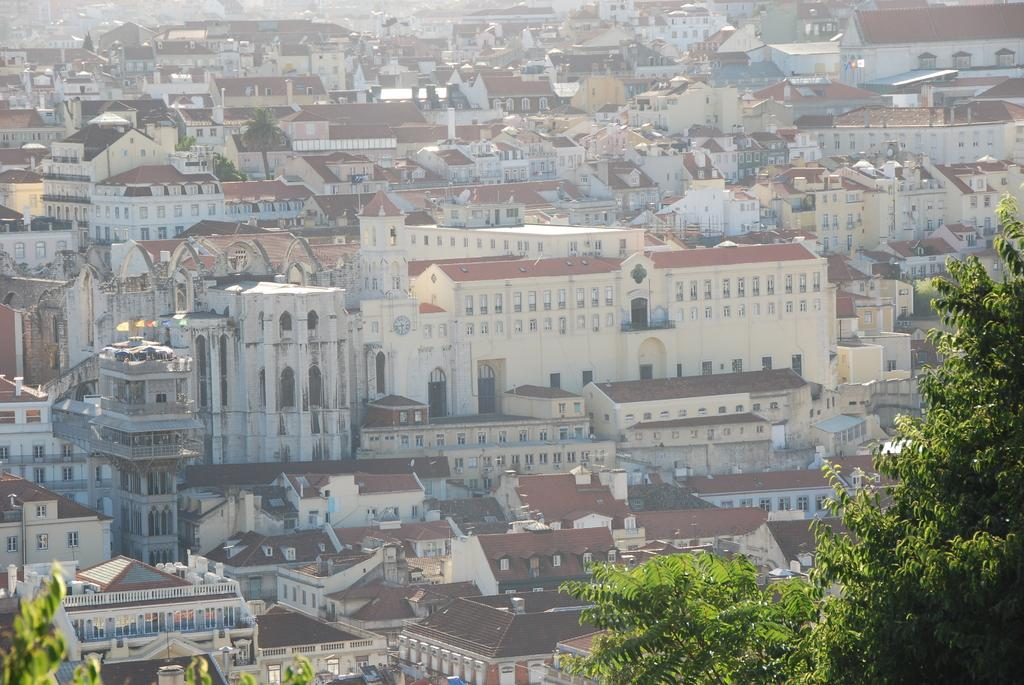What type of structures can be seen in the image? There are houses and buildings in the image. Where are the trees located in the image? Trees are visible at the bottom of the image. What type of pan is being used to push the trees in the image? There is no pan or pushing of trees present in the image. 